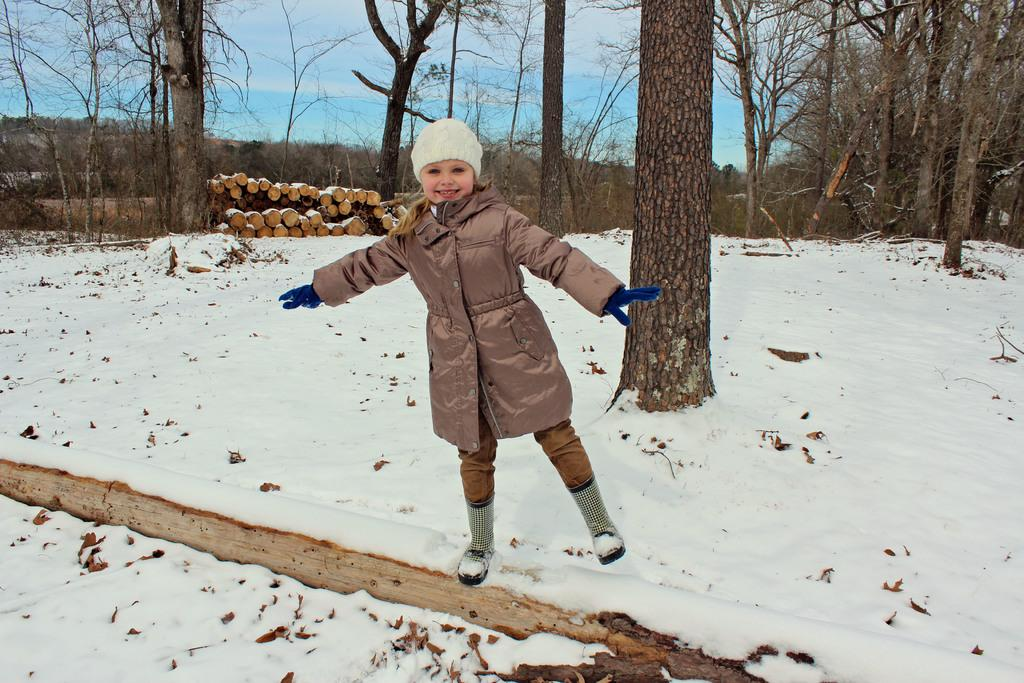What is the main subject of the image? There is a child in the image. What is the child standing on? The child is standing on the snow. What can be seen in the background of the image? There are trees and logs in the background of the image, along with sky visible in the background. What is the condition of the sky in the image? Clouds are present in the sky. What is the ground made of in the image? Snow is visible on the ground. What type of rings can be seen on the child's wrist in the image? There are no rings visible on the child's wrist in the image. What is the stem of the tree in the image used for? There is no specific tree mentioned in the image, and therefore no stem to discuss its use. 